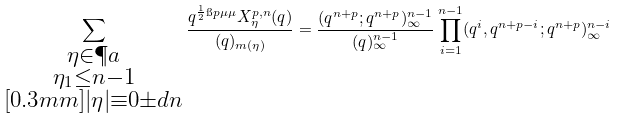Convert formula to latex. <formula><loc_0><loc_0><loc_500><loc_500>\sum _ { \substack { \eta \in \P a \\ \eta _ { 1 } \leq n - 1 \\ [ 0 . 3 m m ] | \eta | \equiv 0 \pm d { n } } } \frac { q ^ { \frac { 1 } { 2 } \i p { \mu } { \mu } } X _ { \eta } ^ { p , n } ( q ) } { ( q ) _ { m ( \eta ) } } = \frac { ( q ^ { n + p } ; q ^ { n + p } ) _ { \infty } ^ { n - 1 } } { ( q ) _ { \infty } ^ { n - 1 } } \prod _ { i = 1 } ^ { n - 1 } ( q ^ { i } , q ^ { n + p - i } ; q ^ { n + p } ) _ { \infty } ^ { n - i }</formula> 